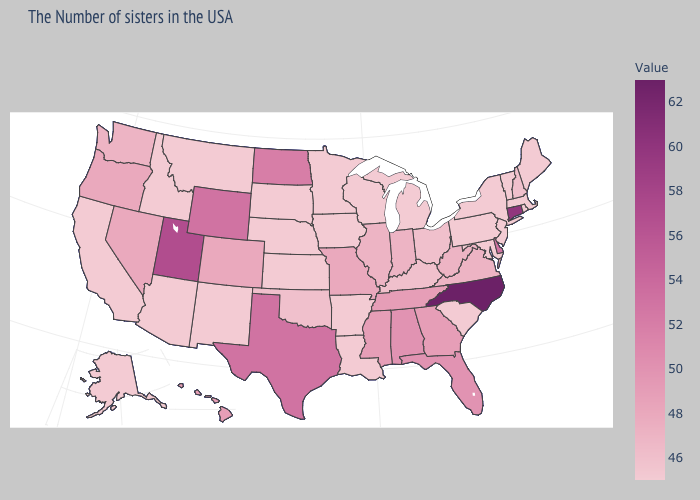Among the states that border Utah , which have the lowest value?
Be succinct. New Mexico, Arizona, Idaho. Does the map have missing data?
Write a very short answer. No. Which states have the lowest value in the USA?
Be succinct. Maine, Massachusetts, Rhode Island, Vermont, New York, New Jersey, Maryland, Pennsylvania, South Carolina, Michigan, Wisconsin, Louisiana, Arkansas, Minnesota, Iowa, Kansas, Nebraska, South Dakota, New Mexico, Montana, Arizona, Idaho, California, Alaska. Which states have the lowest value in the USA?
Quick response, please. Maine, Massachusetts, Rhode Island, Vermont, New York, New Jersey, Maryland, Pennsylvania, South Carolina, Michigan, Wisconsin, Louisiana, Arkansas, Minnesota, Iowa, Kansas, Nebraska, South Dakota, New Mexico, Montana, Arizona, Idaho, California, Alaska. Among the states that border Ohio , which have the highest value?
Concise answer only. West Virginia, Indiana. Does Mississippi have a higher value than Oklahoma?
Write a very short answer. Yes. Does Michigan have the lowest value in the MidWest?
Concise answer only. Yes. Which states have the highest value in the USA?
Keep it brief. North Carolina. 